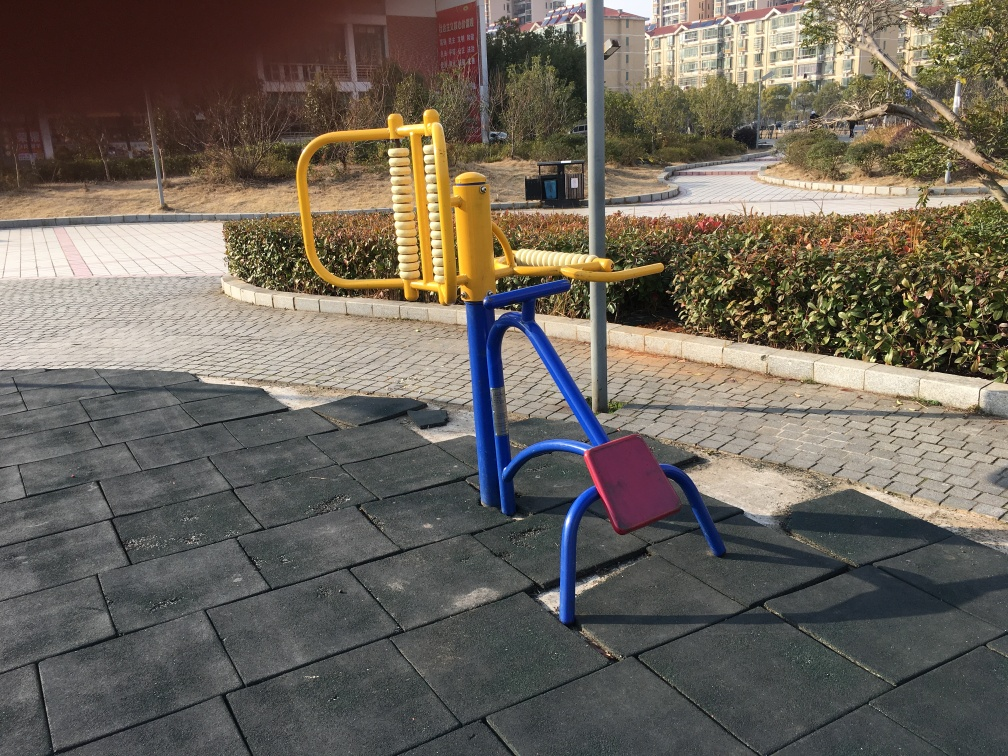Is the equipment in the image meant for children or adults? The equipment shown in the image appears to be designed for adults. It's outdoor fitness equipment, which typically features elements for enhancing physical strength and cardiovascular health. What might be the purpose of this design? This design encourages healthy lifestyles by providing a free, accessible means for outdoor exercise to adults who visit the park. The equipment is crafted to withstand outdoor conditions and offer various workout options. 